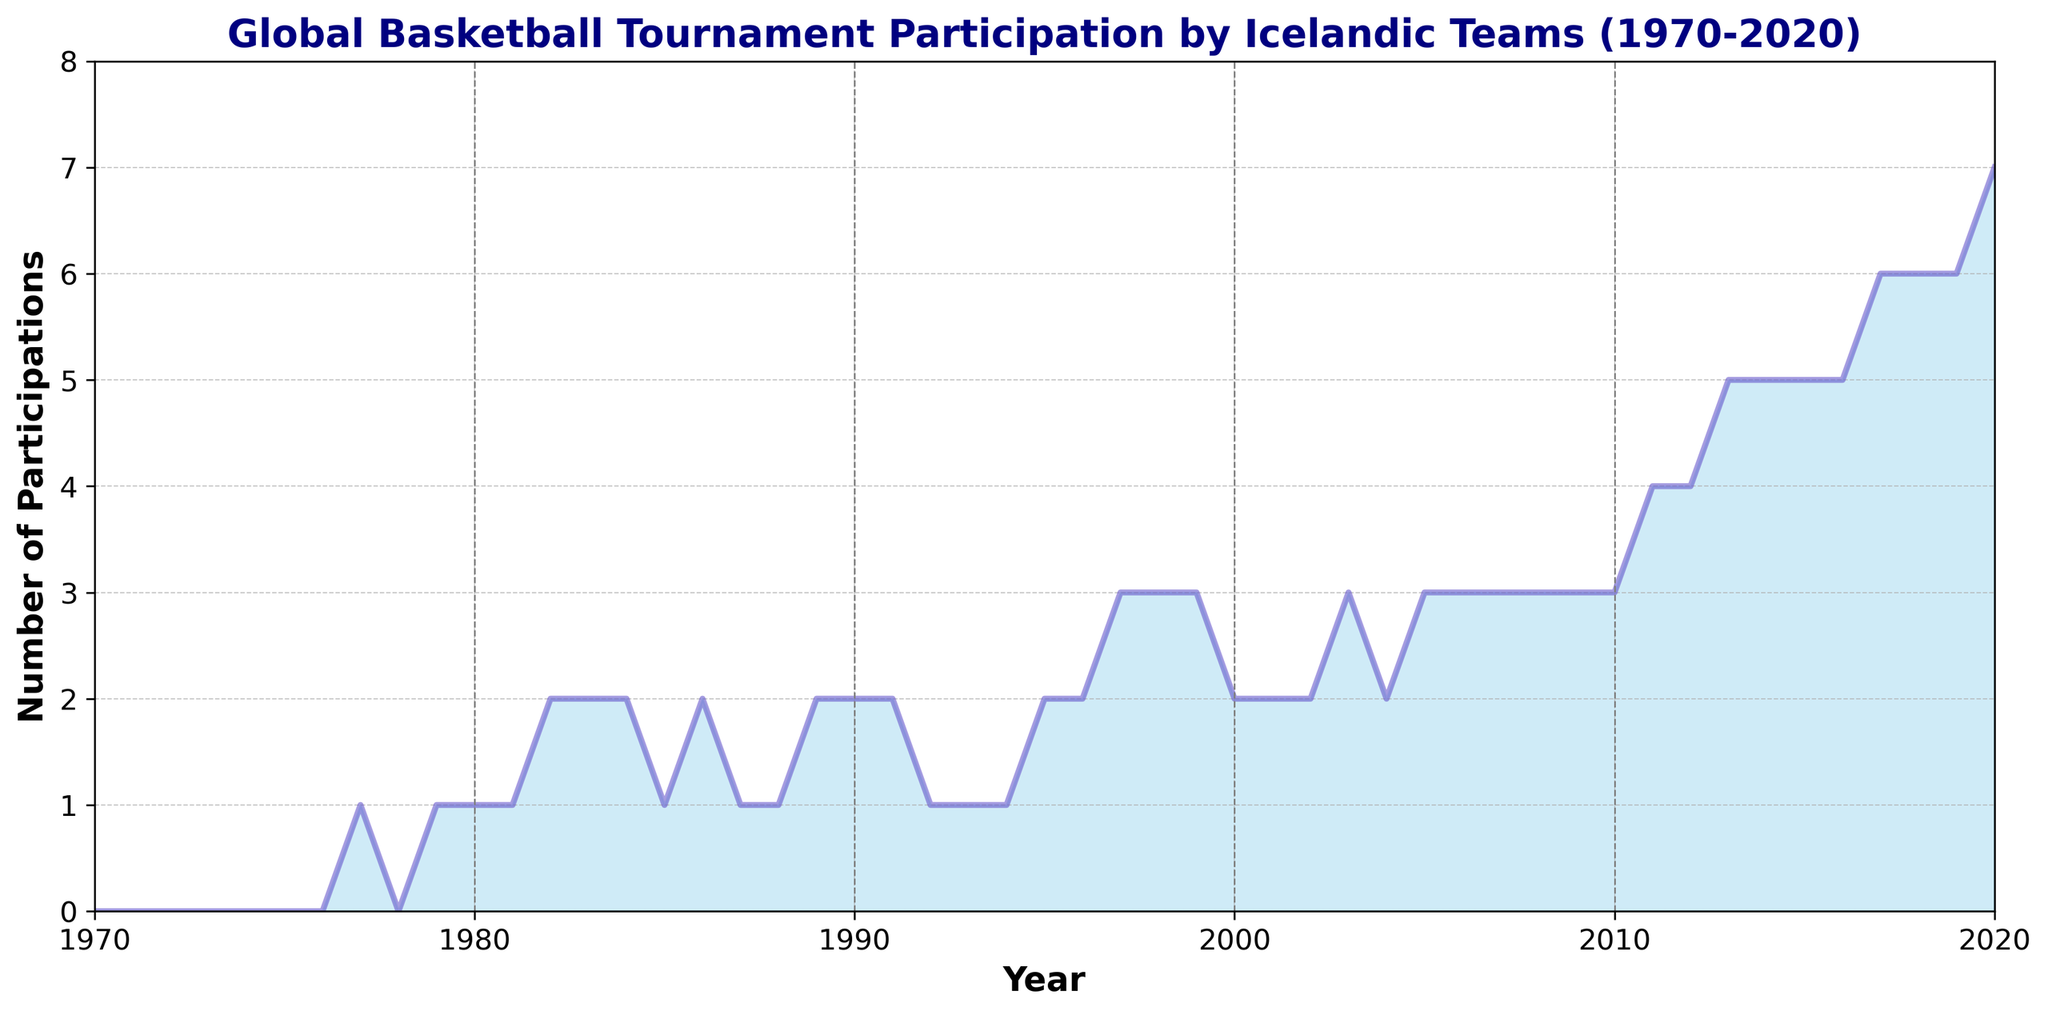What decade shows the most significant increase in participation? The participation in the 2010s increased dramatically from 3 in 2010 to 7 in 2020. This is the highest increase compared to other decades shown in the chart.
Answer: 2010s How many tournaments did Icelandic teams participate in the year 1982? Referring to the figure, the participation level in 1982 is marked at 2.
Answer: 2 Compare the participation between 1977 and 1987. Which year had more participations? By looking at the figure, in 1977 there was 1 participation, and in 1987 there was also 1 participation. Both years had the same number of participations.
Answer: They are equal What is the average participation from 1990 to 1999? The participation numbers from 1990 to 1999 are: 2, 2, 1, 1, 1, 2, 2, 3, 3, 3. Summing these up gives 20, and there are 10 years. Hence, the average is 20/10 = 2.
Answer: 2 Which decade had the least number of participations overall? From 1970 to 1979, the participation numbers are: 0, 0, 0, 0, 0, 0, 1, 0, 1, 1, which sum to 3. This is the lowest compared to other decades.
Answer: 1970s What was the total number of participations over the entire period from 1970 to 2020? Summing all the participation numbers from 1970 to 2020 gives a total of 101 participations.
Answer: 101 By how much did the participation increase from 2013 to 2014? In 2013, the participation was 5, and in 2014, it increased to 5. The increase is 5 - 5 = 0.
Answer: 0 What is the participation count in the year with the highest recorded participation? The highest participation count in the chart occurs in 2020, with a total of 7 participations.
Answer: 7 Compare the participations in 1983 and 2003. How many more participations were there in 2003 compared to 1983? In 1983, there were 2 participations, and in 2003, there were 3 participations. The difference is 3 - 2 = 1.
Answer: 1 In which year did participation jump from 2 to 3 within the provided time frame? According to the figure, participation increased from 2 to 3 between 2002 and 2003.
Answer: 2003 